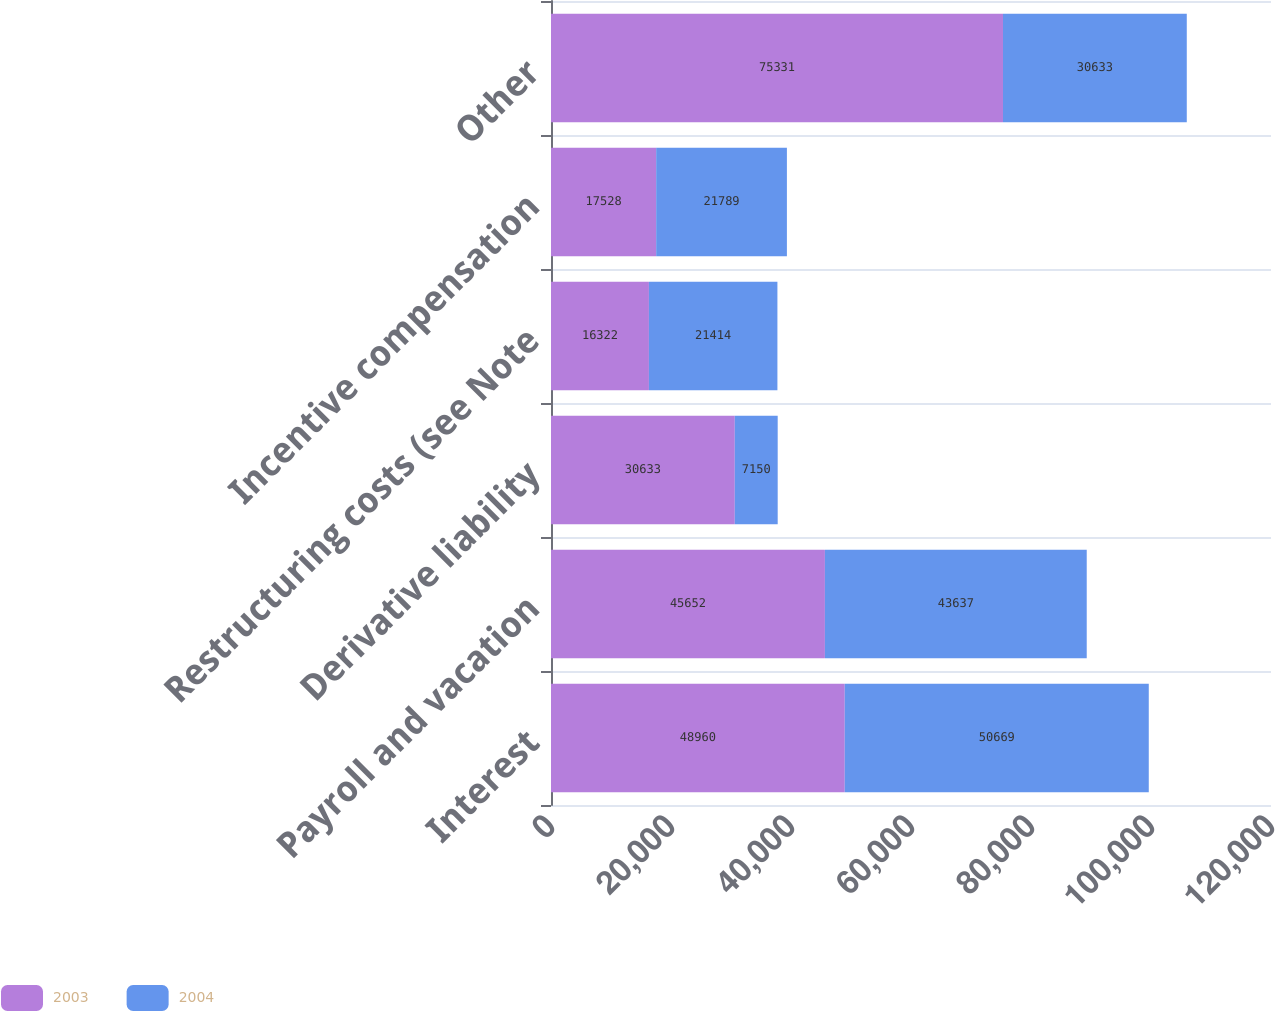<chart> <loc_0><loc_0><loc_500><loc_500><stacked_bar_chart><ecel><fcel>Interest<fcel>Payroll and vacation<fcel>Derivative liability<fcel>Restructuring costs (see Note<fcel>Incentive compensation<fcel>Other<nl><fcel>2003<fcel>48960<fcel>45652<fcel>30633<fcel>16322<fcel>17528<fcel>75331<nl><fcel>2004<fcel>50669<fcel>43637<fcel>7150<fcel>21414<fcel>21789<fcel>30633<nl></chart> 